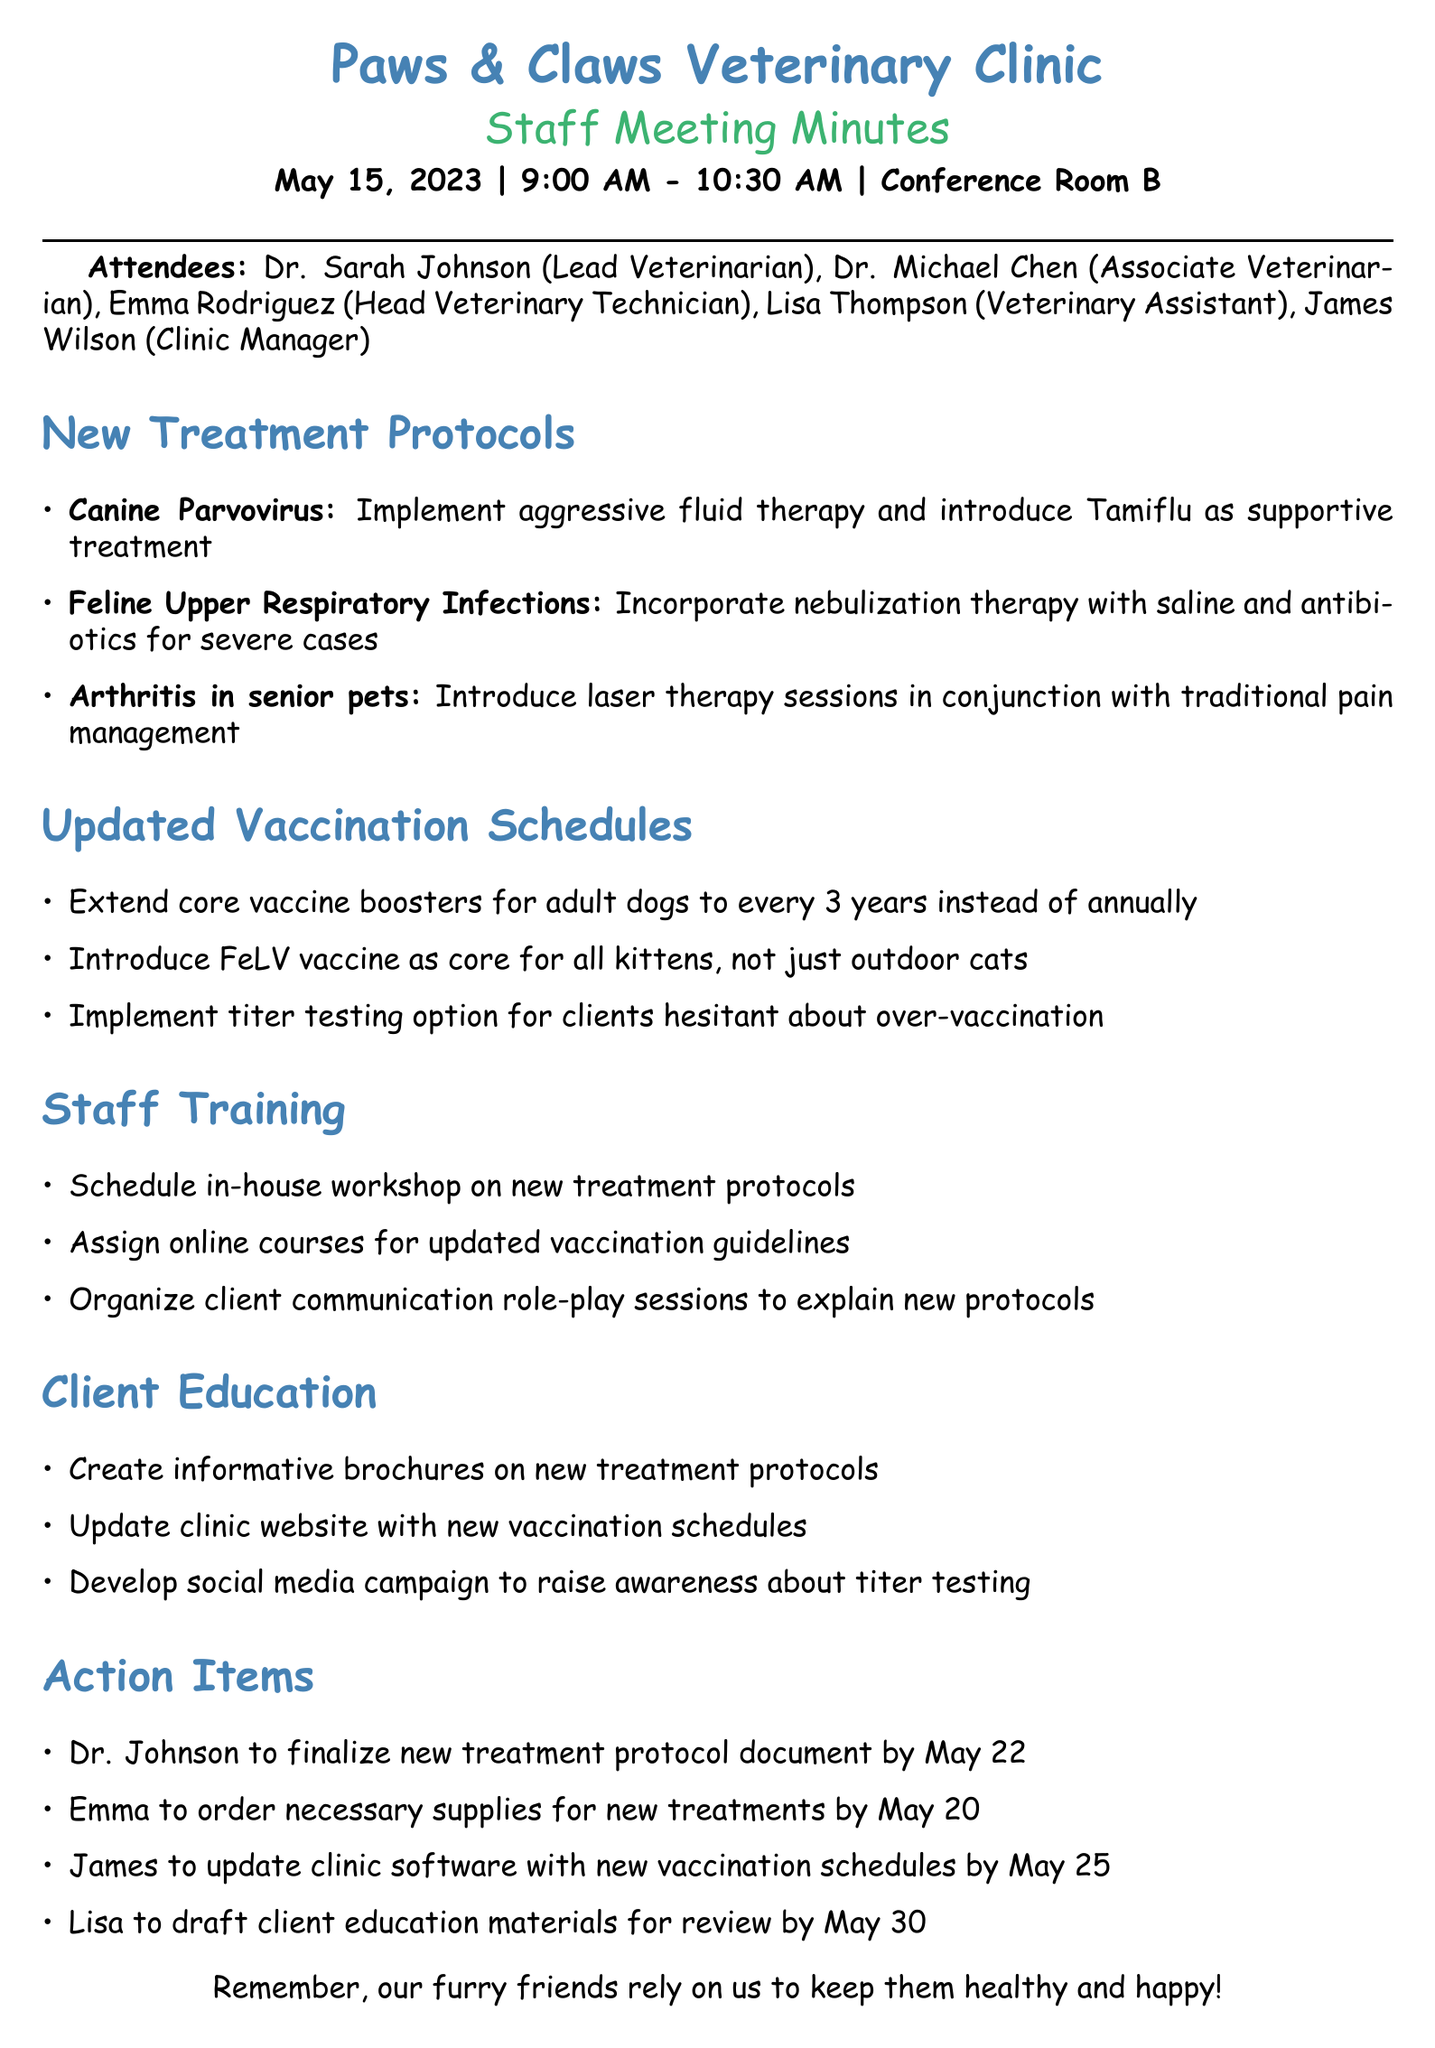What is the meeting date? The meeting date is explicitly stated in the document.
Answer: May 15, 2023 Who is the lead veterinarian? This piece of information is found in the attendees list.
Answer: Dr. Sarah Johnson What new treatment is introduced for canine parvovirus? This information is detailed under the treatment protocols.
Answer: Aggressive fluid therapy and Tamiflu How often are core vaccine boosters now administered for adult dogs? The updated vaccination schedule provides this detail.
Answer: Every 3 years What is the purpose of the social media campaign? The client education initiatives include this information.
Answer: Raise awareness about titer testing By when should Dr. Johnson finalize the new treatment protocol document? The action items section contains this timeline.
Answer: May 22 What will the in-house workshop cover? Staff training points outline this topic.
Answer: New treatment protocols Which vaccination was introduced as core for all kittens? The updated vaccination schedules mention this change.
Answer: FeLV vaccine 